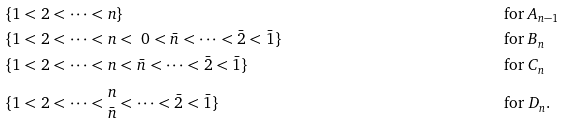<formula> <loc_0><loc_0><loc_500><loc_500>& \{ 1 < 2 < \cdots < n \} & & \text {for $A_{n-1}$} \\ & \{ 1 < 2 < \cdots < n < \ 0 < \bar { n } < \cdots < \bar { 2 } < \bar { 1 } \} & & \text {for $B_{n}$} \\ & \{ 1 < 2 < \cdots < n < \bar { n } < \cdots < \bar { 2 } < \bar { 1 } \} & & \text {for $C_{n}$} \\ & \{ 1 < 2 < \cdots < \begin{matrix} { n } \\ { \bar { n } } \end{matrix} < \cdots < \bar { 2 } < \bar { 1 } \} & & \text {for $D_{n}$.}</formula> 